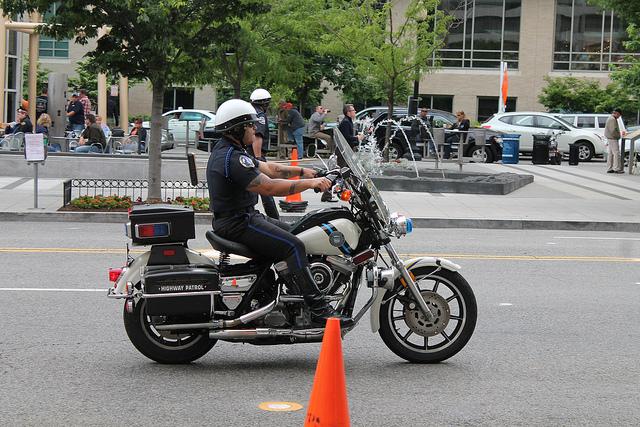Is the motorcycle in the street?
Quick response, please. Yes. Is this an emergency?
Be succinct. No. What is the man looking at?
Short answer required. Road. Is the cop going fast?
Write a very short answer. No. Is the cop male or female?
Quick response, please. Male. What is on the orange cones?
Concise answer only. Nothing. What type of pants is the motorcycle rider wearing?
Write a very short answer. Leather. 